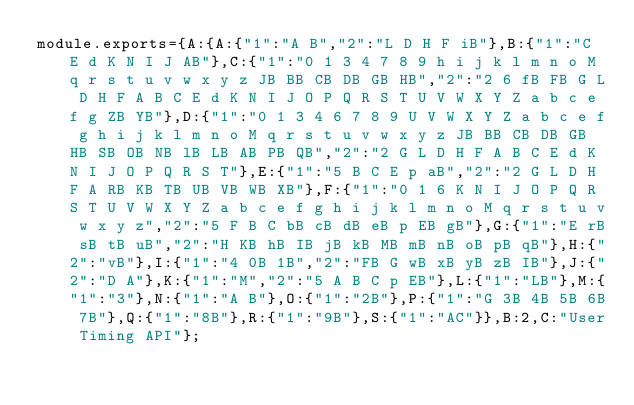<code> <loc_0><loc_0><loc_500><loc_500><_JavaScript_>module.exports={A:{A:{"1":"A B","2":"L D H F iB"},B:{"1":"C E d K N I J AB"},C:{"1":"0 1 3 4 7 8 9 h i j k l m n o M q r s t u v w x y z JB BB CB DB GB HB","2":"2 6 fB FB G L D H F A B C E d K N I J O P Q R S T U V W X Y Z a b c e f g ZB YB"},D:{"1":"0 1 3 4 6 7 8 9 U V W X Y Z a b c e f g h i j k l m n o M q r s t u v w x y z JB BB CB DB GB HB SB OB NB lB LB AB PB QB","2":"2 G L D H F A B C E d K N I J O P Q R S T"},E:{"1":"5 B C E p aB","2":"2 G L D H F A RB KB TB UB VB WB XB"},F:{"1":"0 1 6 K N I J O P Q R S T U V W X Y Z a b c e f g h i j k l m n o M q r s t u v w x y z","2":"5 F B C bB cB dB eB p EB gB"},G:{"1":"E rB sB tB uB","2":"H KB hB IB jB kB MB mB nB oB pB qB"},H:{"2":"vB"},I:{"1":"4 0B 1B","2":"FB G wB xB yB zB IB"},J:{"2":"D A"},K:{"1":"M","2":"5 A B C p EB"},L:{"1":"LB"},M:{"1":"3"},N:{"1":"A B"},O:{"1":"2B"},P:{"1":"G 3B 4B 5B 6B 7B"},Q:{"1":"8B"},R:{"1":"9B"},S:{"1":"AC"}},B:2,C:"User Timing API"};
</code> 